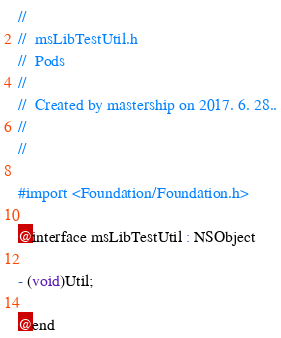<code> <loc_0><loc_0><loc_500><loc_500><_C_>//
//  msLibTestUtil.h
//  Pods
//
//  Created by mastership on 2017. 6. 28..
//
//

#import <Foundation/Foundation.h>

@interface msLibTestUtil : NSObject

- (void)Util;

@end
</code> 